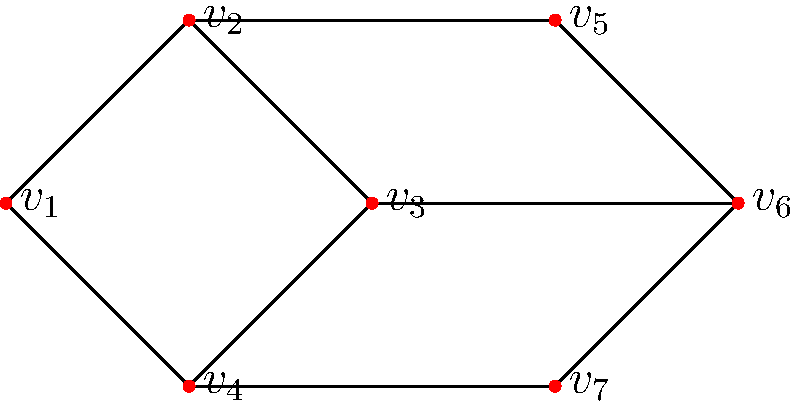As a young forward looking to optimize your training schedule, you're tasked with coloring a graph representing different training zones to avoid conflicts. The graph above shows 7 vertices ($v_1$ to $v_7$) representing different training areas. Connected vertices cannot have the same color as they represent conflicting schedules. What is the minimum number of colors needed to properly color this graph? To determine the minimum number of colors needed, we'll use the greedy coloring algorithm:

1) Start with vertex $v_1$. Assign it color 1.
   Colors used: 1

2) Move to $v_2$. It's adjacent to $v_1$, so it needs a new color.
   Colors used: 1, 2

3) For $v_3$:
   - Adjacent to $v_2$ (color 2)
   - Can use color 1
   Colors used: 1, 2

4) For $v_4$:
   - Adjacent to $v_1$ (color 1), $v_2$ (color 2), $v_3$ (color 1)
   - Needs a new color
   Colors used: 1, 2, 3

5) For $v_5$:
   - Adjacent to $v_2$ (color 2)
   - Can use color 1
   Colors used: 1, 2, 3

6) For $v_6$:
   - Adjacent to $v_3$ (color 1), $v_5$ (color 1)
   - Can use color 2
   Colors used: 1, 2, 3

7) For $v_7$:
   - Adjacent to $v_4$ (color 3), $v_6$ (color 2)
   - Can use color 1
   Colors used: 1, 2, 3

After coloring all vertices, we find that 3 colors are sufficient to properly color the graph.
Answer: 3 colors 